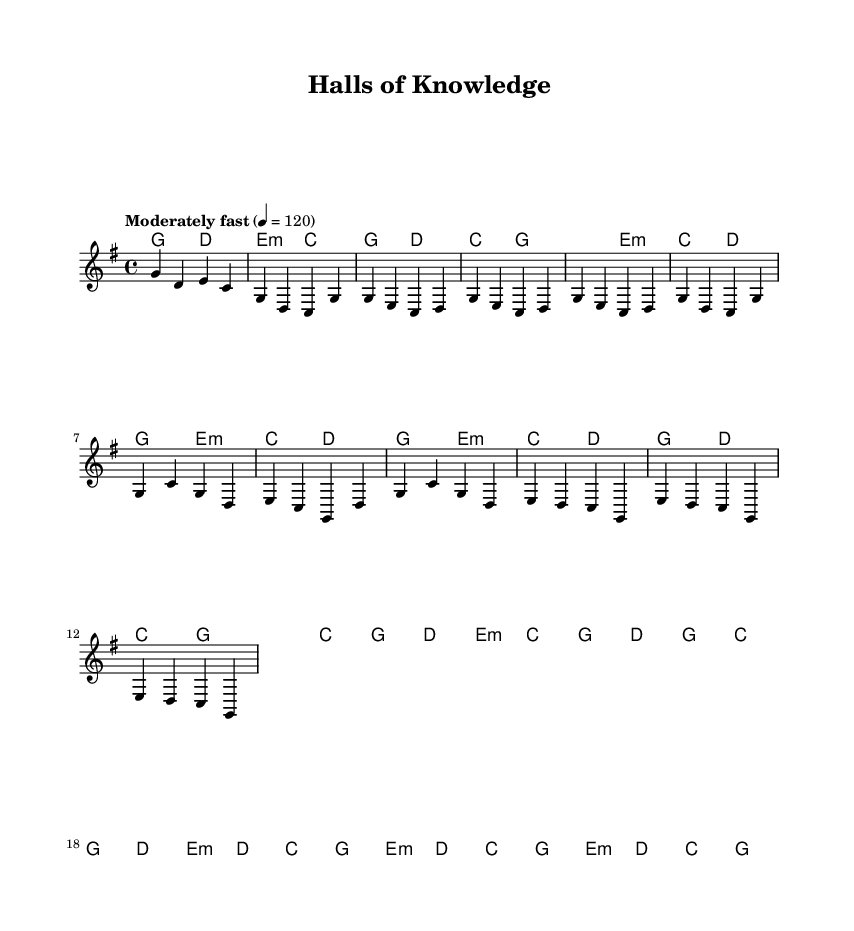What is the key signature of this music? The key signature shows one sharp, which indicates the key of G major. In G major, the notes include G, A, B, C, D, E, and F#.
Answer: G major What is the time signature of this music? The time signature is indicated at the beginning of the piece, which is 4/4. This means there are four beats in each measure and a quarter note gets one beat.
Answer: 4/4 What is the tempo of this music? The tempo marking is placed at the beginning and states "Moderately fast" at a speed of 120 beats per minute. This indicates a brisk pacing that is not too rapid.
Answer: 120 What is the first chord in the song? The first chord appears at the start of the piece in the harmonies section, which is a G major chord followed by a D major chord. Therefore, the very first chord is G major.
Answer: G What melodic interval appears frequently in the verse? By examining the melody in the verse, notes such as G to E and C to D are prominent. The most common interval is a step (second), primarily between adjacent notes.
Answer: Second What musical style does this piece represent? The piece's title, "Halls of Knowledge," along with its upbeat rhythm and instrumentation typical to the genre, indicate it embodies Country Rock, which often features themes of patriotism and education.
Answer: Country Rock 